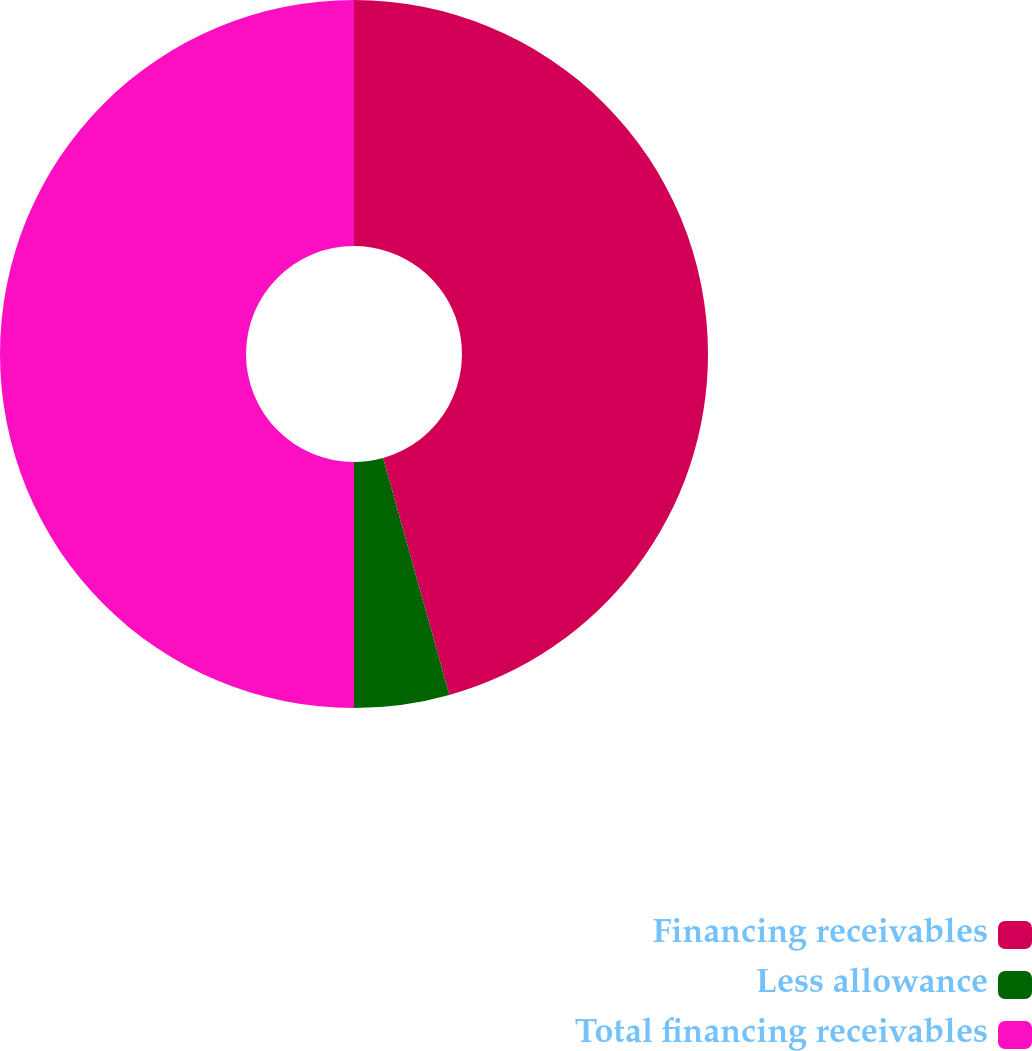Convert chart. <chart><loc_0><loc_0><loc_500><loc_500><pie_chart><fcel>Financing receivables<fcel>Less allowance<fcel>Total financing receivables<nl><fcel>45.66%<fcel>4.34%<fcel>50.0%<nl></chart> 